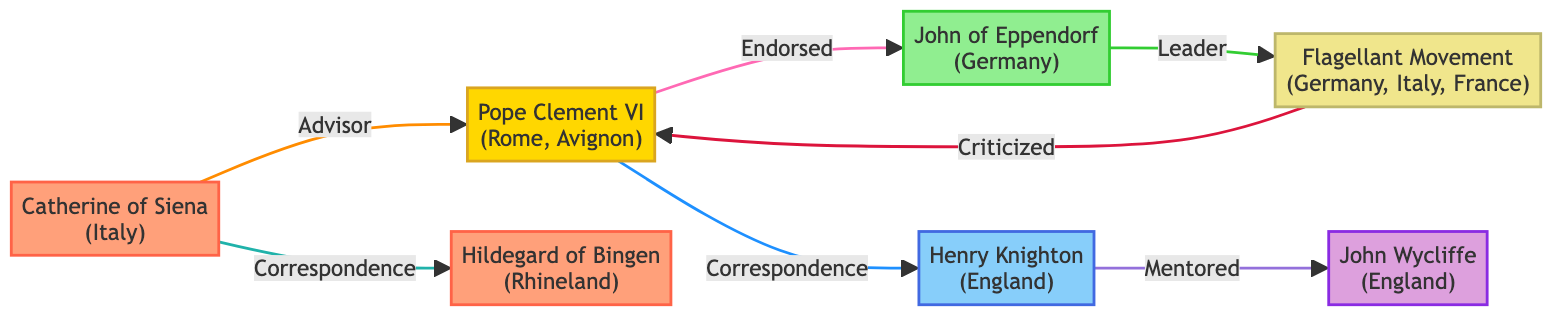What is the relationship between Pope Clement VI and John of Eppendorf? The diagram shows an arrow from Pope Clement VI to John of Eppendorf with the label "Endorsed." This indicates that Pope Clement VI endorsed John of Eppendorf.
Answer: Endorsed How many communities are influenced by the Flagellant Movement? The Flagellant Movement is connected to three communities: Germany, Italy, and France, as indicated next to its label. Therefore, it influences three communities.
Answer: 3 Who mentored John Wycliffe? The diagram shows an arrow from Henry Knighton to John Wycliffe labeled "Mentored," indicating that Henry Knighton mentored him.
Answer: Henry Knighton Which religious figure had correspondence with Hildegard of Bingen? There is an arrow from Catherine of Siena to Hildegard of Bingen labeled "Correspondence," showing that Catherine of Siena had correspondence with her.
Answer: Catherine of Siena Which community is influenced by Pope Clement VI? Pope Clement VI is linked to the communities of Rome and Avignon, as indicated in the diagram next to his label.
Answer: Rome, Avignon How many total nodes are represented in the diagram? The diagram contains a total of seven nodes that represent the key religious figures and movements during the period of the Black Death.
Answer: 7 What relationship does the Flagellant Movement have with Pope Clement VI? The diagram shows an arrow from the Flagellant Movement to Pope Clement VI labeled "Criticized," indicating that the Flagellant Movement criticized Pope Clement VI.
Answer: Criticized Which role does Hildegard of Bingen hold? The label next to Hildegard of Bingen in the diagram identifies her role as a Mystic.
Answer: Mystic What distinguishes John of Eppendorf in the diagram? John of Eppendorf is uniquely linked to the Flagellant Movement as its "Leader," highlighted by an arrow pointing from him to the movement.
Answer: Leader 